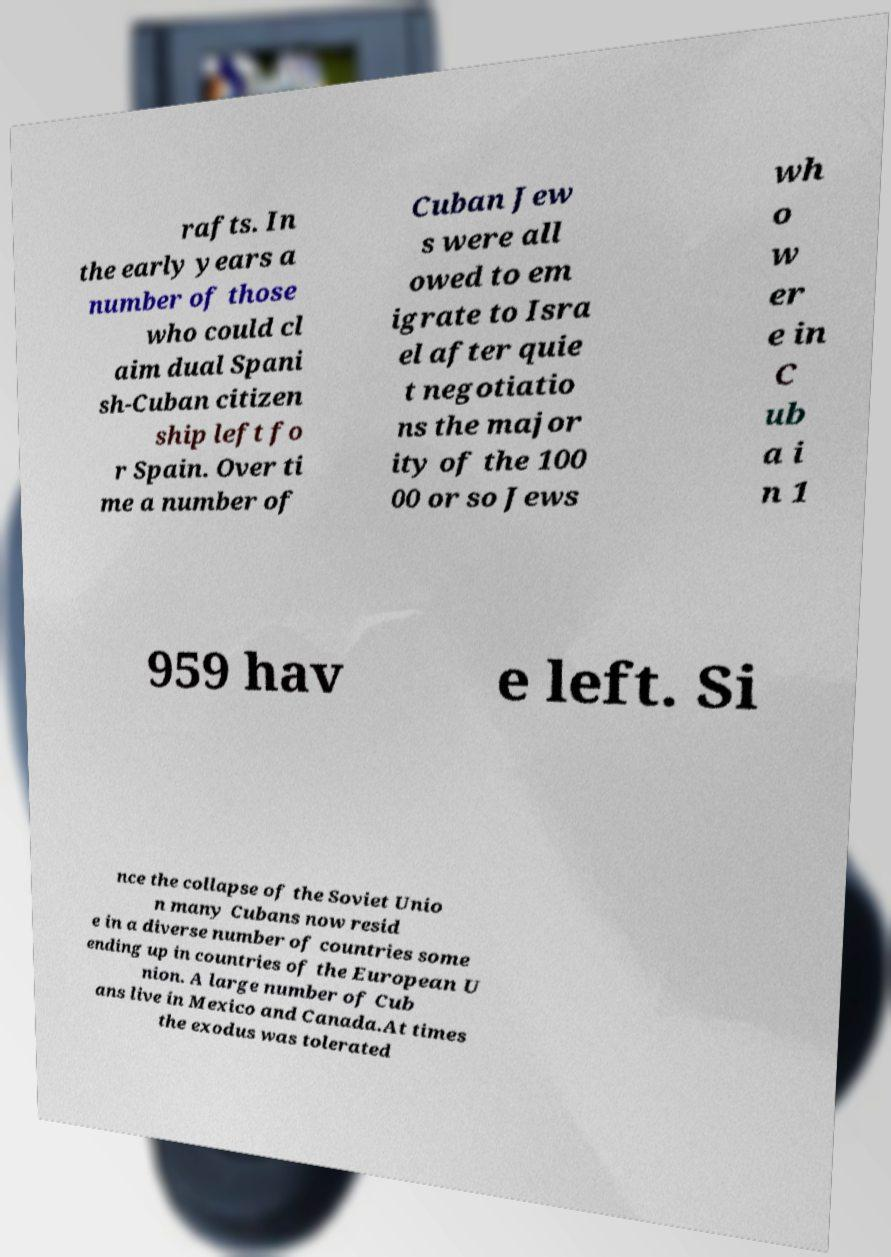Could you assist in decoding the text presented in this image and type it out clearly? rafts. In the early years a number of those who could cl aim dual Spani sh-Cuban citizen ship left fo r Spain. Over ti me a number of Cuban Jew s were all owed to em igrate to Isra el after quie t negotiatio ns the major ity of the 100 00 or so Jews wh o w er e in C ub a i n 1 959 hav e left. Si nce the collapse of the Soviet Unio n many Cubans now resid e in a diverse number of countries some ending up in countries of the European U nion. A large number of Cub ans live in Mexico and Canada.At times the exodus was tolerated 